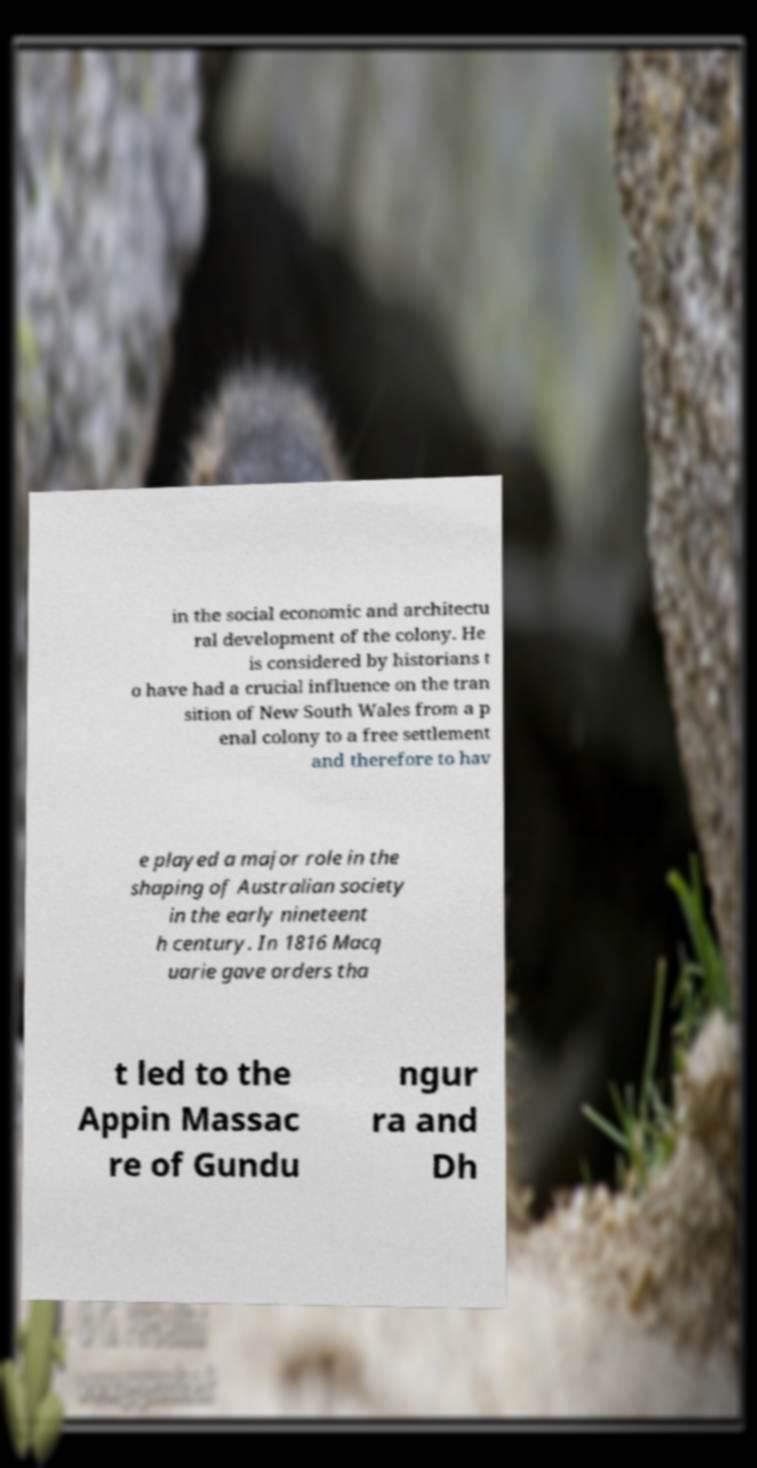Please read and relay the text visible in this image. What does it say? in the social economic and architectu ral development of the colony. He is considered by historians t o have had a crucial influence on the tran sition of New South Wales from a p enal colony to a free settlement and therefore to hav e played a major role in the shaping of Australian society in the early nineteent h century. In 1816 Macq uarie gave orders tha t led to the Appin Massac re of Gundu ngur ra and Dh 